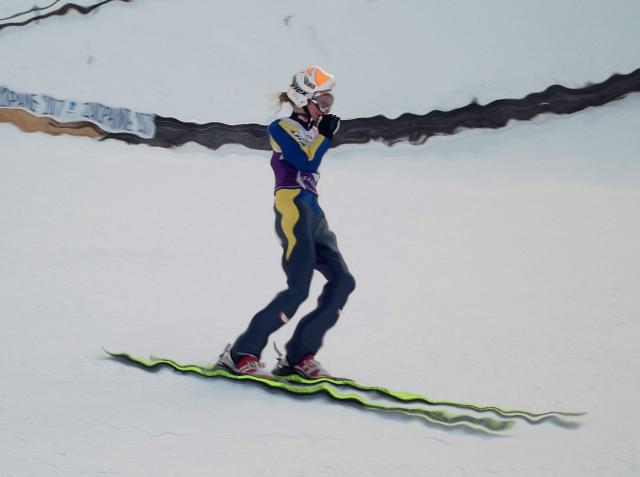Is there visible noise in the image?
 No 